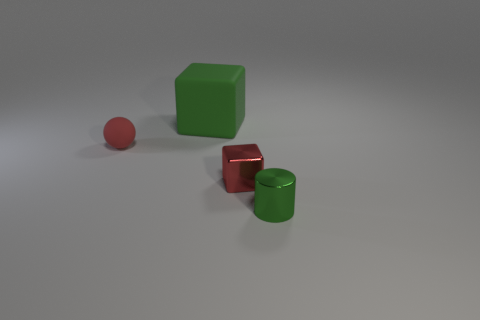There is a tiny green object that is made of the same material as the small cube; what is its shape?
Provide a succinct answer. Cylinder. How many other objects are the same shape as the small red shiny object?
Your response must be concise. 1. There is a tiny green object; is it the same shape as the red thing that is on the right side of the green block?
Provide a short and direct response. No. The thing that is the same color as the tiny sphere is what shape?
Provide a short and direct response. Cube. The red rubber object that is the same size as the green metal cylinder is what shape?
Ensure brevity in your answer.  Sphere. There is a cylinder that is the same color as the large block; what is it made of?
Keep it short and to the point. Metal. Are there any small cubes left of the tiny cylinder?
Offer a terse response. Yes. Is there another object of the same shape as the tiny red metal object?
Keep it short and to the point. Yes. There is a red object in front of the tiny red rubber sphere; does it have the same shape as the green thing that is behind the green metallic thing?
Offer a very short reply. Yes. Is there a red cube that has the same size as the green cylinder?
Your answer should be very brief. Yes. 